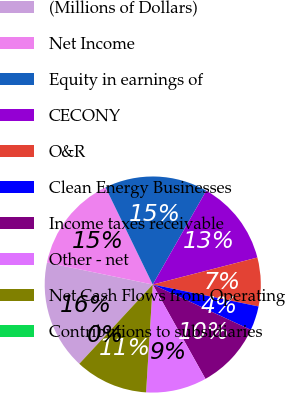<chart> <loc_0><loc_0><loc_500><loc_500><pie_chart><fcel>(Millions of Dollars)<fcel>Net Income<fcel>Equity in earnings of<fcel>CECONY<fcel>O&R<fcel>Clean Energy Businesses<fcel>Income taxes receivable<fcel>Other - net<fcel>Net Cash Flows from Operating<fcel>Contributions to subsidiaries<nl><fcel>16.36%<fcel>14.54%<fcel>15.45%<fcel>12.73%<fcel>7.27%<fcel>3.64%<fcel>10.0%<fcel>9.09%<fcel>10.91%<fcel>0.0%<nl></chart> 